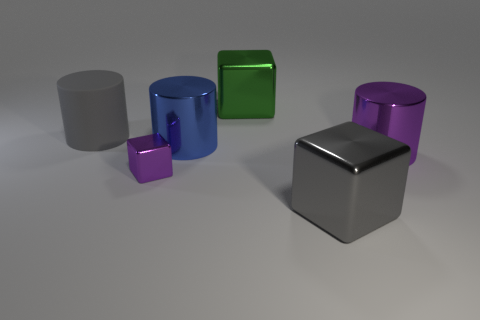Add 2 tiny blue metallic spheres. How many objects exist? 8 Add 1 blue metallic objects. How many blue metallic objects are left? 2 Add 6 big blue objects. How many big blue objects exist? 7 Subtract 0 green spheres. How many objects are left? 6 Subtract all large gray objects. Subtract all big blocks. How many objects are left? 2 